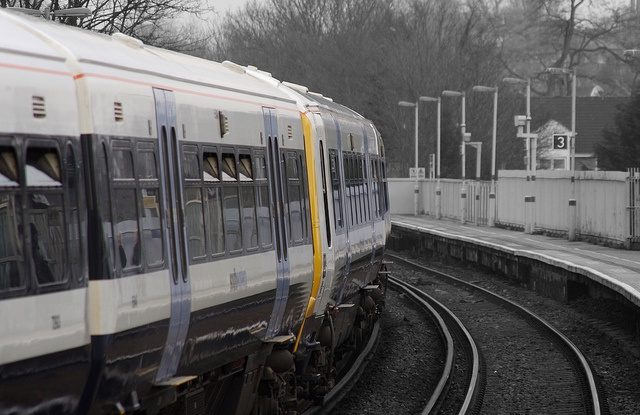Describe the objects in this image and their specific colors. I can see a train in black, darkgray, gray, and lightgray tones in this image. 